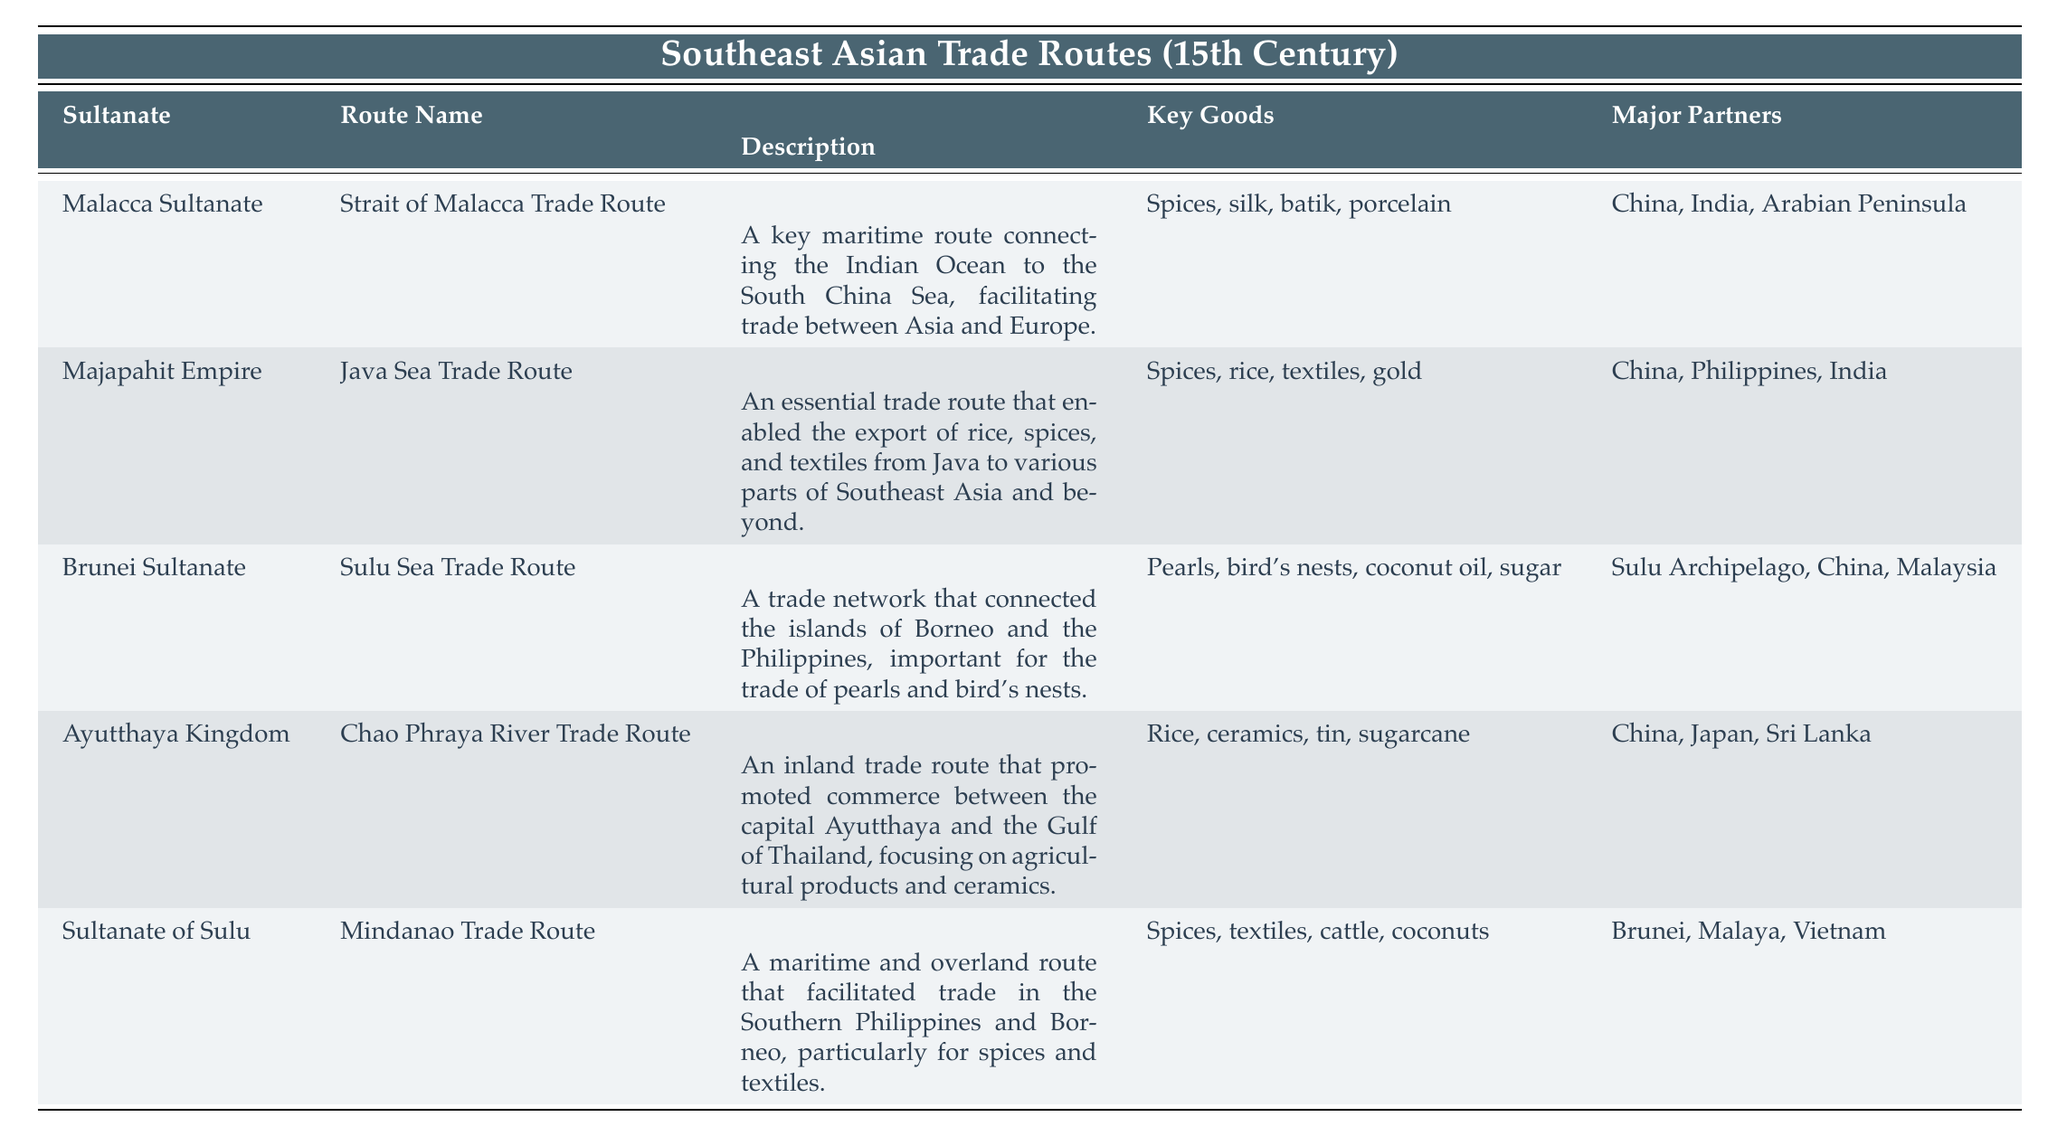What is the name of the trade route established by the Malacca Sultanate? The table indicates that the trade route established by the Malacca Sultanate is called the "Strait of Malacca Trade Route."
Answer: Strait of Malacca Trade Route Which goods were traded via the Java Sea Trade Route? According to the table, the key goods traded through the Java Sea Trade Route included spices, rice, textiles, and gold.
Answer: Spices, rice, textiles, gold Did the Brunei Sultanate's trade route focus on agricultural products? The description of the Sulu Sea Trade Route linked to the Brunei Sultanate does not mention agricultural products but focuses on pearls and bird's nests. Therefore, the statement is false.
Answer: No Which Sultanate had trade partners that included Japan? The Ayutthaya Kingdom's trade route had major partners that included Japan, as noted in the table.
Answer: Ayutthaya Kingdom How many trade routes were established in 1400? There are three trade routes listed in the table that were established in the year 1400: the Strait of Malacca Trade Route, the Sulu Sea Trade Route, and the Mindanao Trade Route. So, the total is 3.
Answer: 3 What are the key goods for the Chao Phraya River Trade Route? The table specifies that the key goods for the Chao Phraya River Trade Route included rice, ceramics, tin, and sugarcane.
Answer: Rice, ceramics, tin, sugarcane Is the majority of trade in the Sulu Sea Trade Route focused on spices and textiles? The table indicates that the key goods for the Sulu Sea Trade Route are indeed spices and textiles, making the statement true.
Answer: Yes Which trade route facilitates the trade of rice from Java to other regions? The Java Sea Trade Route is confirmed in the table as the trade route that facilitates the export of rice from Java to different parts of Southeast Asia and beyond.
Answer: Java Sea Trade Route 